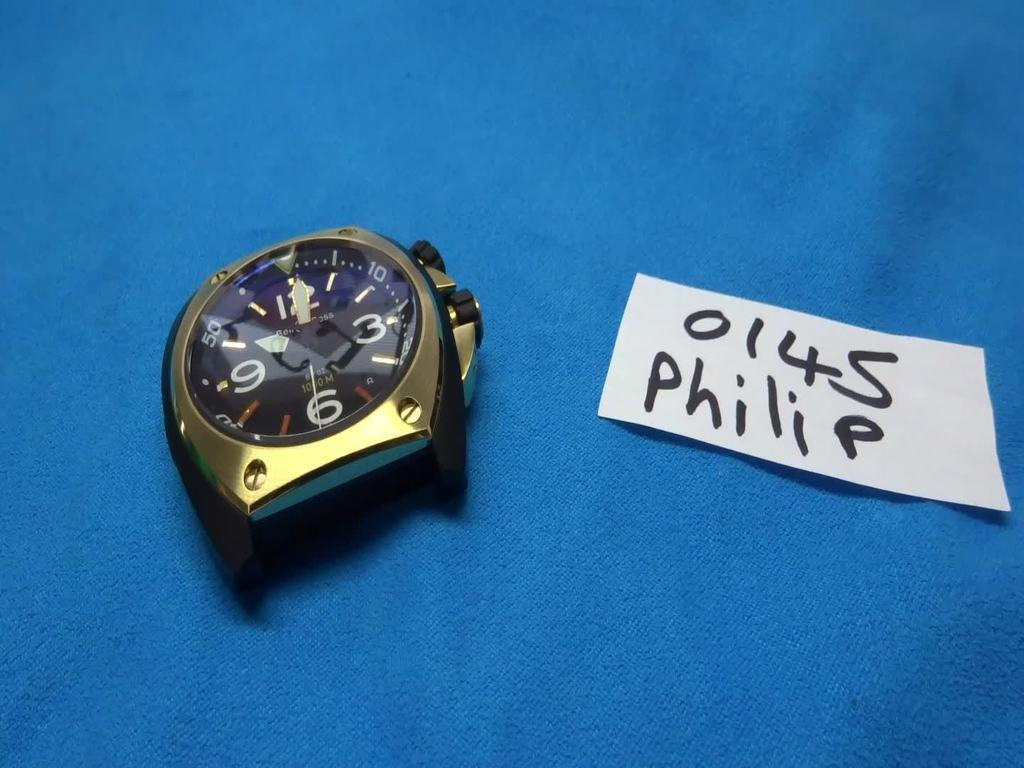<image>
Present a compact description of the photo's key features. Part of a watch with a 0145 Philip label. 